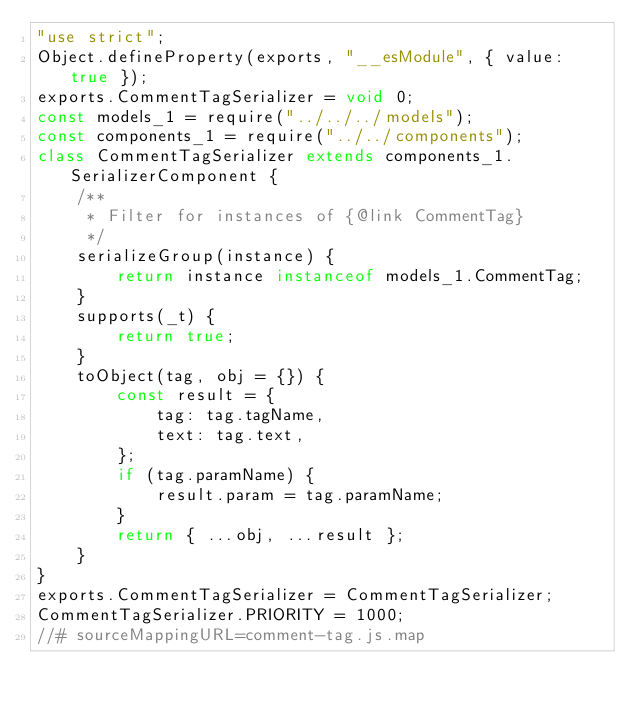Convert code to text. <code><loc_0><loc_0><loc_500><loc_500><_JavaScript_>"use strict";
Object.defineProperty(exports, "__esModule", { value: true });
exports.CommentTagSerializer = void 0;
const models_1 = require("../../../models");
const components_1 = require("../../components");
class CommentTagSerializer extends components_1.SerializerComponent {
    /**
     * Filter for instances of {@link CommentTag}
     */
    serializeGroup(instance) {
        return instance instanceof models_1.CommentTag;
    }
    supports(_t) {
        return true;
    }
    toObject(tag, obj = {}) {
        const result = {
            tag: tag.tagName,
            text: tag.text,
        };
        if (tag.paramName) {
            result.param = tag.paramName;
        }
        return { ...obj, ...result };
    }
}
exports.CommentTagSerializer = CommentTagSerializer;
CommentTagSerializer.PRIORITY = 1000;
//# sourceMappingURL=comment-tag.js.map</code> 